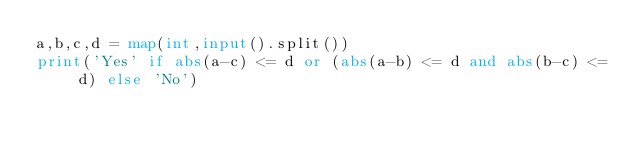<code> <loc_0><loc_0><loc_500><loc_500><_Python_>a,b,c,d = map(int,input().split())
print('Yes' if abs(a-c) <= d or (abs(a-b) <= d and abs(b-c) <= d) else 'No')</code> 